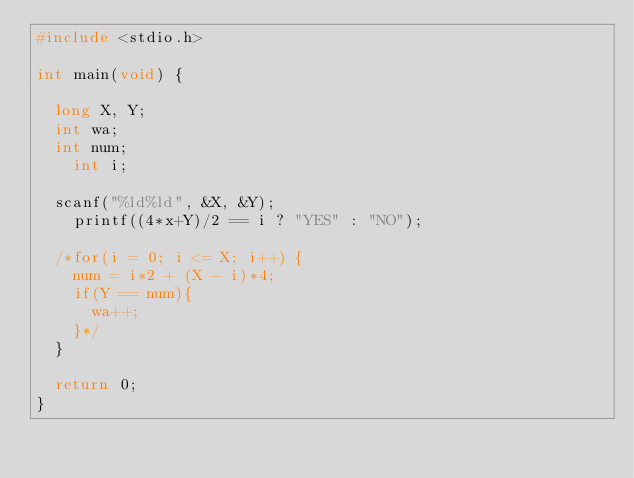Convert code to text. <code><loc_0><loc_0><loc_500><loc_500><_C_>#include <stdio.h>
 
int main(void) {
 
 	long X, Y;
 	int wa;
 	int num;
    int i;
 
 	scanf("%ld%ld", &X, &Y);
    printf((4*x+Y)/2 == i ? "YES" : "NO");
 
 	/*for(i = 0; i <= X; i++) {
 		num = i*2 + (X - i)*4;
	 	if(Y == num){
	 		wa++;
	 	}*/
 	}
	
	return 0;
}
</code> 